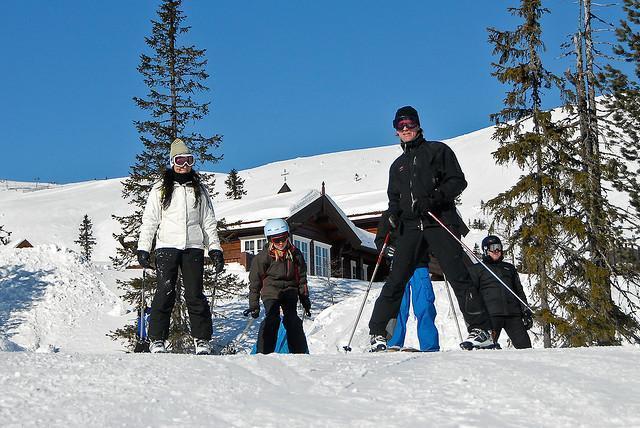How many people are wearing black pants?
Give a very brief answer. 4. How many people are in the picture?
Give a very brief answer. 5. 